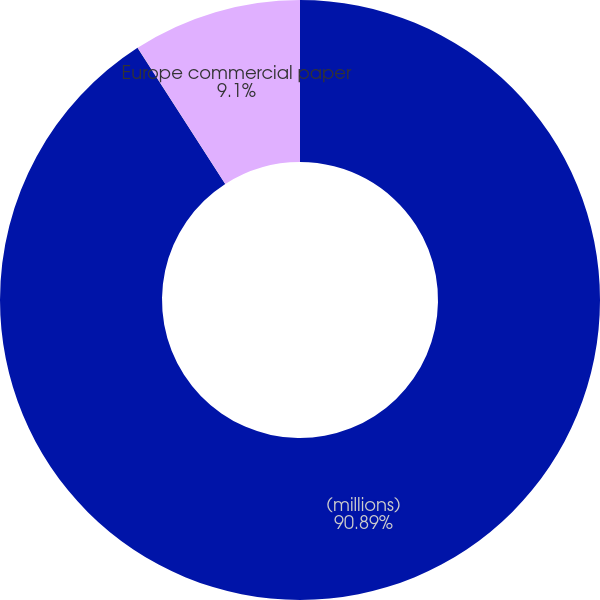Convert chart to OTSL. <chart><loc_0><loc_0><loc_500><loc_500><pie_chart><fcel>(millions)<fcel>US commercial paper<fcel>Europe commercial paper<nl><fcel>90.89%<fcel>0.01%<fcel>9.1%<nl></chart> 